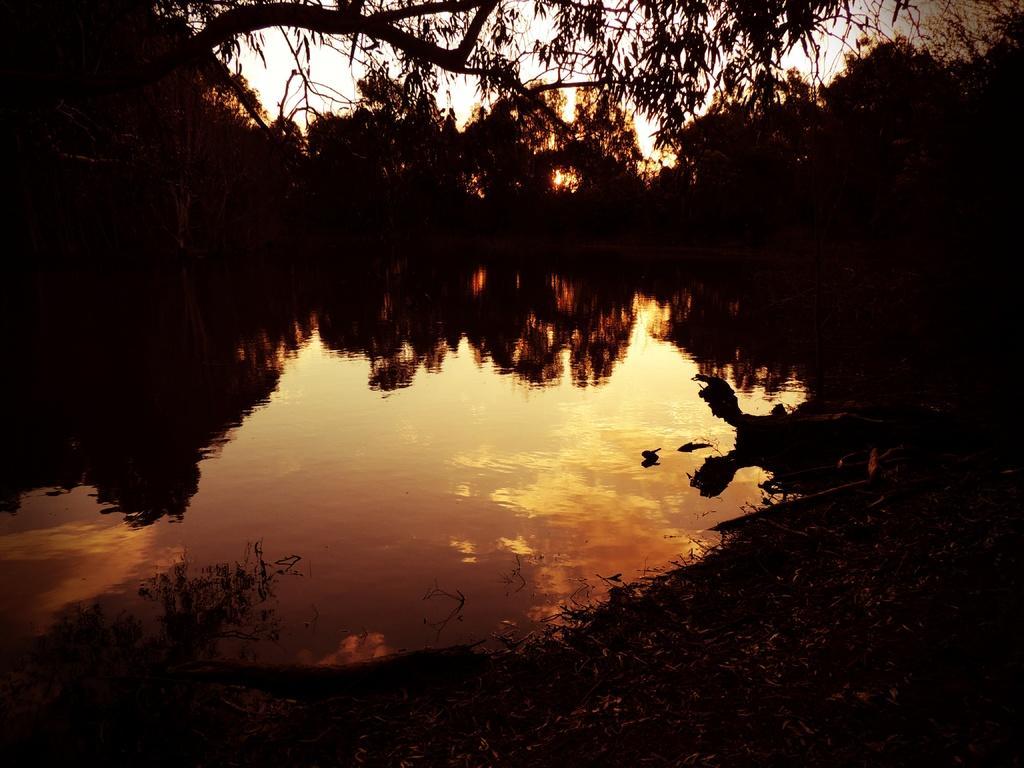Could you give a brief overview of what you see in this image? This picture is dark, we can see water, trees and sky. On this water we can see reflection of trees and sky with clouds. 